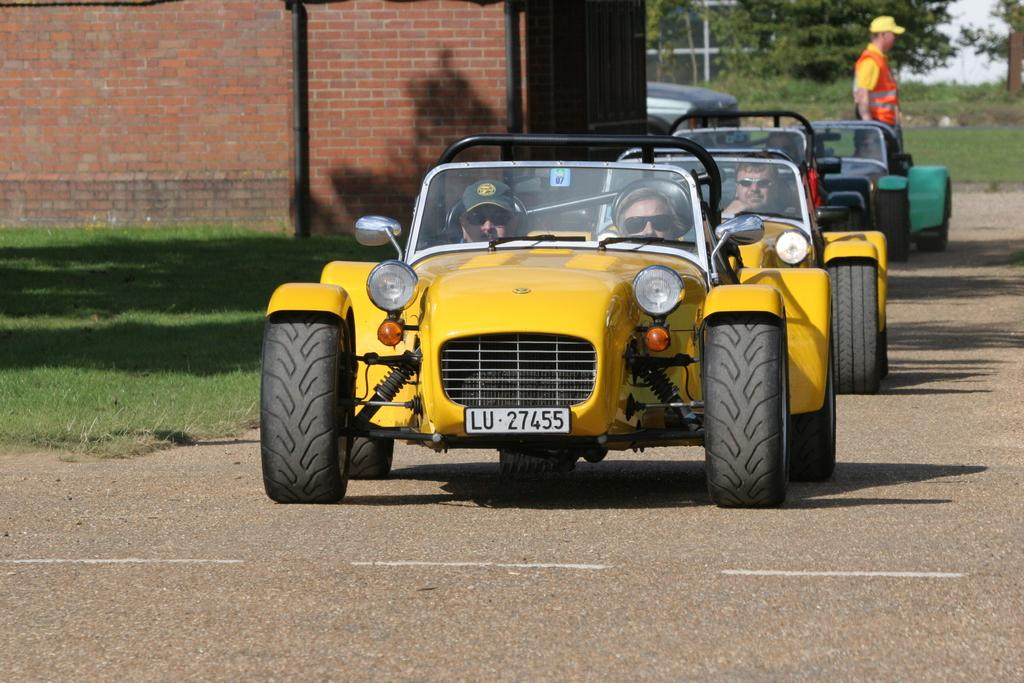What are the people in the image doing? The people in the image are riding vehicles on the road. Can you describe the person who is not riding a vehicle? There is a person standing on the road. What type of natural elements can be seen in the image? Grass, trees, and plants are visible in the image. What type of man-made structures are present in the image? Walls and poles are present in the image. What type of sea creature can be seen swimming in the image? There is no sea creature present in the image; it features people riding vehicles and standing on a road. Can you describe the crook's behavior in the image? There is no crook present in the image. 